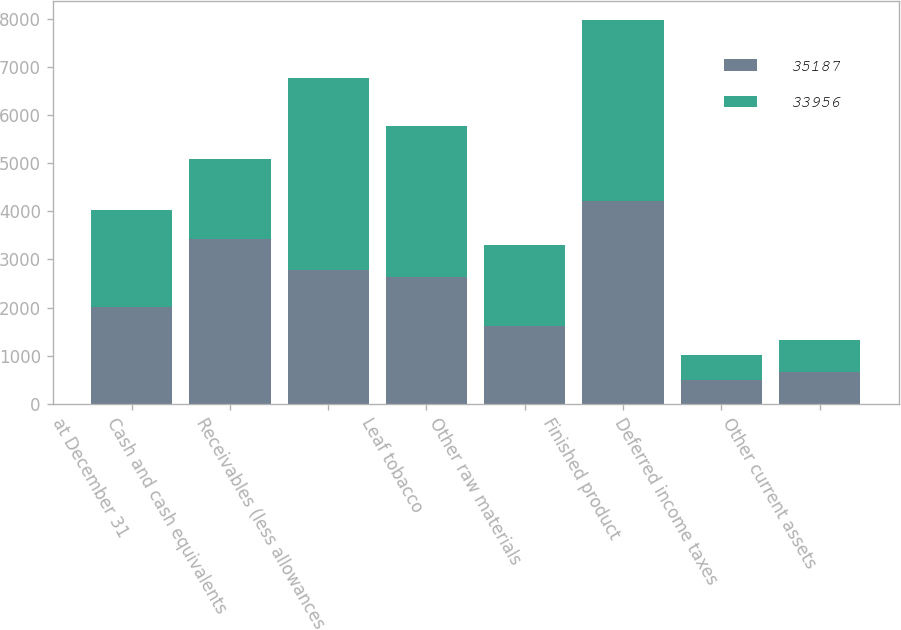<chart> <loc_0><loc_0><loc_500><loc_500><stacked_bar_chart><ecel><fcel>at December 31<fcel>Cash and cash equivalents<fcel>Receivables (less allowances<fcel>Leaf tobacco<fcel>Other raw materials<fcel>Finished product<fcel>Deferred income taxes<fcel>Other current assets<nl><fcel>35187<fcel>2015<fcel>3417<fcel>2778<fcel>2640<fcel>1613<fcel>4220<fcel>488<fcel>648<nl><fcel>33956<fcel>2014<fcel>1682<fcel>4004<fcel>3135<fcel>1696<fcel>3761<fcel>533<fcel>673<nl></chart> 